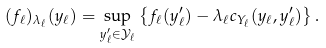Convert formula to latex. <formula><loc_0><loc_0><loc_500><loc_500>( f _ { \ell } ) _ { \lambda _ { \ell } } ( y _ { \ell } ) = \sup _ { y _ { \ell } ^ { \prime } \in \mathcal { Y } _ { \ell } } \left \{ f _ { \ell } ( y _ { \ell } ^ { \prime } ) - \lambda _ { \ell } c _ { Y _ { \ell } } ( y _ { \ell } , y _ { \ell } ^ { \prime } ) \right \} .</formula> 